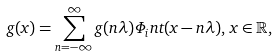Convert formula to latex. <formula><loc_0><loc_0><loc_500><loc_500>g ( x ) = \sum _ { n = - \infty } ^ { \infty } g ( n \lambda ) \Phi _ { i } n t ( x - n \lambda ) , \, x \in \mathbb { R } ,</formula> 